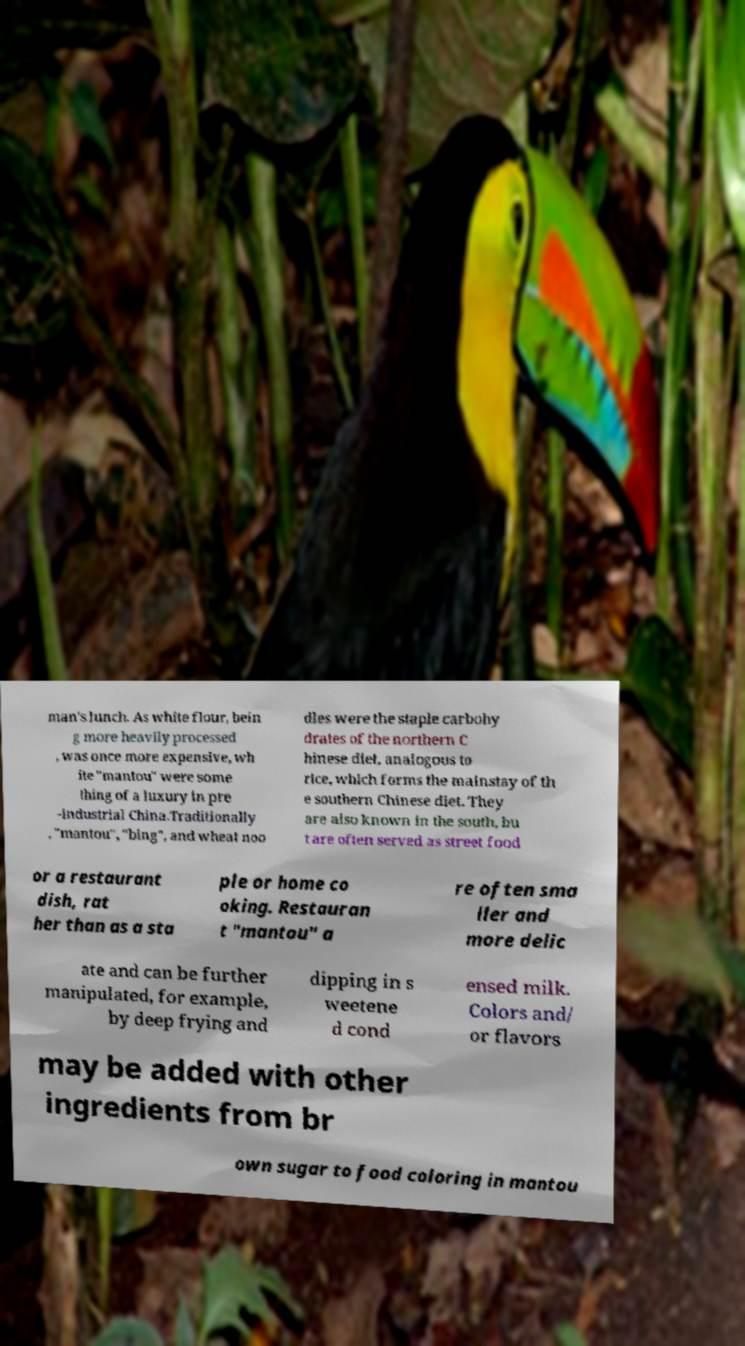Please read and relay the text visible in this image. What does it say? man's lunch. As white flour, bein g more heavily processed , was once more expensive, wh ite "mantou" were some thing of a luxury in pre -industrial China.Traditionally , "mantou", "bing", and wheat noo dles were the staple carbohy drates of the northern C hinese diet, analogous to rice, which forms the mainstay of th e southern Chinese diet. They are also known in the south, bu t are often served as street food or a restaurant dish, rat her than as a sta ple or home co oking. Restauran t "mantou" a re often sma ller and more delic ate and can be further manipulated, for example, by deep frying and dipping in s weetene d cond ensed milk. Colors and/ or flavors may be added with other ingredients from br own sugar to food coloring in mantou 